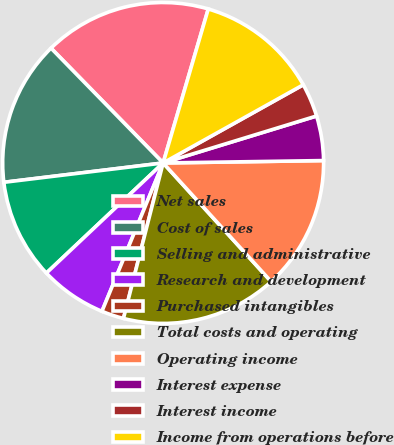<chart> <loc_0><loc_0><loc_500><loc_500><pie_chart><fcel>Net sales<fcel>Cost of sales<fcel>Selling and administrative<fcel>Research and development<fcel>Purchased intangibles<fcel>Total costs and operating<fcel>Operating income<fcel>Interest expense<fcel>Interest income<fcel>Income from operations before<nl><fcel>16.85%<fcel>14.61%<fcel>10.11%<fcel>6.74%<fcel>2.25%<fcel>15.73%<fcel>13.48%<fcel>4.49%<fcel>3.37%<fcel>12.36%<nl></chart> 